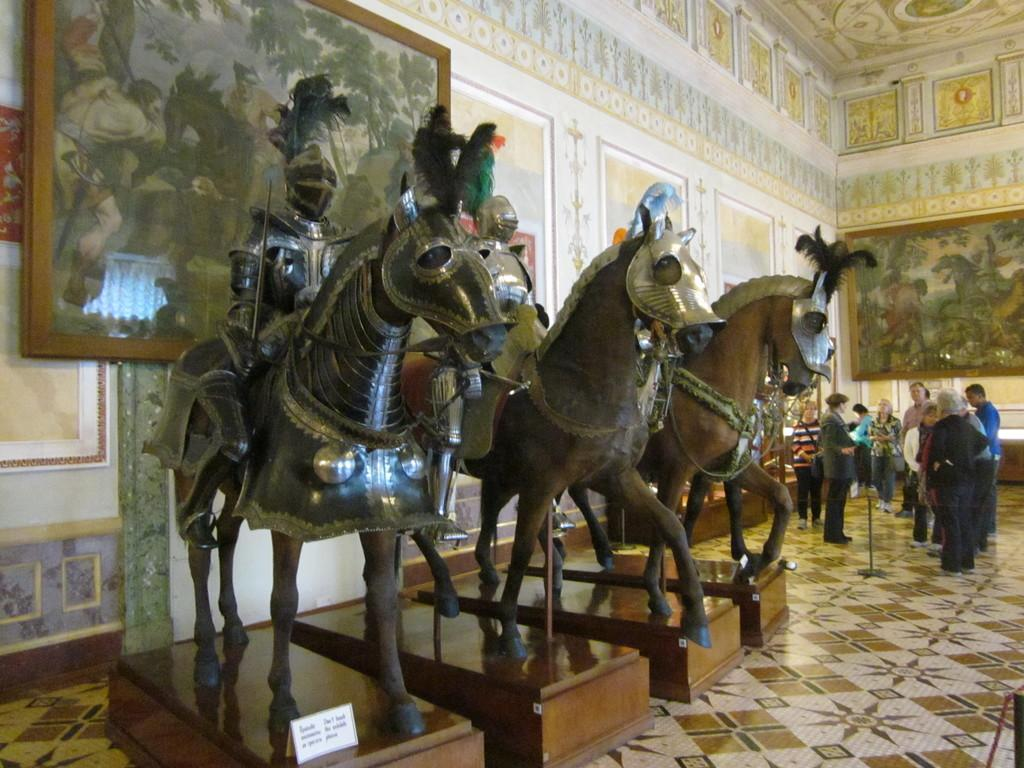What is the main subject in the center of the image? There are statues of horses in the center of the image. What can be seen in the background of the image? There are persons, a painting, photo frames, and a wall in the background of the image. What type of birds are flying in a committee in the image? There are no birds or committees present in the image. 